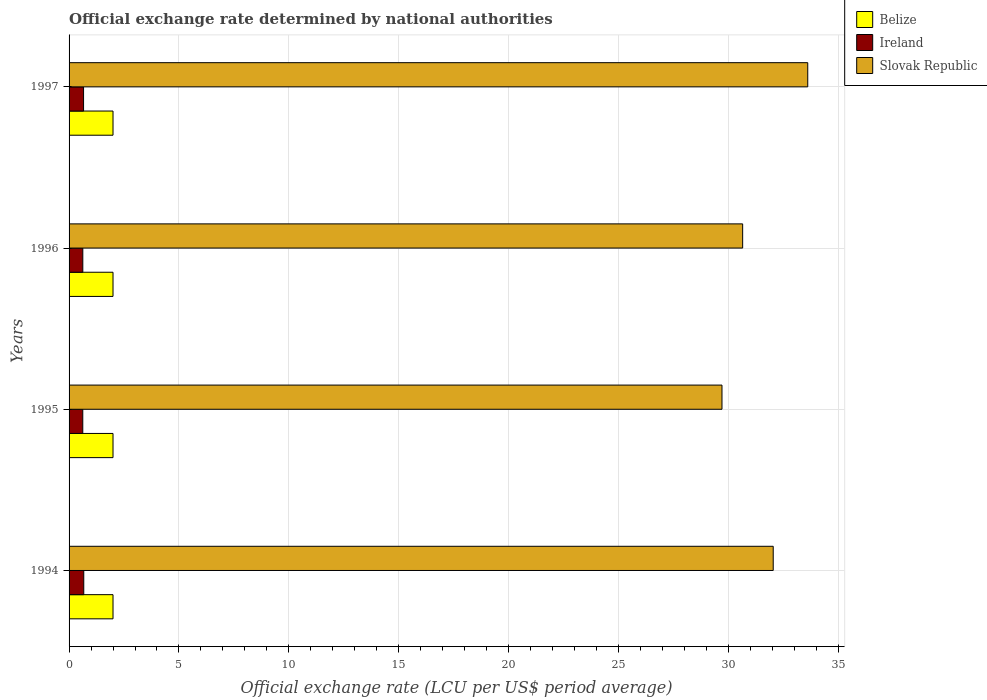How many different coloured bars are there?
Your response must be concise. 3. How many groups of bars are there?
Keep it short and to the point. 4. How many bars are there on the 3rd tick from the bottom?
Offer a terse response. 3. In how many cases, is the number of bars for a given year not equal to the number of legend labels?
Your answer should be compact. 0. What is the official exchange rate in Belize in 1996?
Your answer should be compact. 2. Across all years, what is the maximum official exchange rate in Slovak Republic?
Offer a very short reply. 33.62. Across all years, what is the minimum official exchange rate in Slovak Republic?
Your answer should be compact. 29.71. In which year was the official exchange rate in Ireland minimum?
Your response must be concise. 1995. What is the difference between the official exchange rate in Ireland in 1994 and that in 1997?
Provide a short and direct response. 0.01. What is the difference between the official exchange rate in Belize in 1994 and the official exchange rate in Ireland in 1995?
Ensure brevity in your answer.  1.38. In the year 1994, what is the difference between the official exchange rate in Ireland and official exchange rate in Belize?
Your answer should be very brief. -1.33. In how many years, is the official exchange rate in Slovak Republic greater than 16 LCU?
Make the answer very short. 4. What is the ratio of the official exchange rate in Ireland in 1994 to that in 1997?
Offer a terse response. 1.01. Is the official exchange rate in Slovak Republic in 1994 less than that in 1995?
Your response must be concise. No. What is the difference between the highest and the second highest official exchange rate in Slovak Republic?
Your answer should be compact. 1.57. What is the difference between the highest and the lowest official exchange rate in Ireland?
Offer a terse response. 0.04. In how many years, is the official exchange rate in Ireland greater than the average official exchange rate in Ireland taken over all years?
Provide a succinct answer. 2. What does the 3rd bar from the top in 1995 represents?
Provide a short and direct response. Belize. What does the 1st bar from the bottom in 1994 represents?
Offer a very short reply. Belize. Is it the case that in every year, the sum of the official exchange rate in Belize and official exchange rate in Ireland is greater than the official exchange rate in Slovak Republic?
Keep it short and to the point. No. How many bars are there?
Your response must be concise. 12. Does the graph contain grids?
Keep it short and to the point. Yes. Where does the legend appear in the graph?
Keep it short and to the point. Top right. How are the legend labels stacked?
Offer a terse response. Vertical. What is the title of the graph?
Give a very brief answer. Official exchange rate determined by national authorities. What is the label or title of the X-axis?
Your answer should be very brief. Official exchange rate (LCU per US$ period average). What is the label or title of the Y-axis?
Your answer should be very brief. Years. What is the Official exchange rate (LCU per US$ period average) of Belize in 1994?
Your response must be concise. 2. What is the Official exchange rate (LCU per US$ period average) in Ireland in 1994?
Keep it short and to the point. 0.67. What is the Official exchange rate (LCU per US$ period average) of Slovak Republic in 1994?
Keep it short and to the point. 32.04. What is the Official exchange rate (LCU per US$ period average) of Ireland in 1995?
Offer a very short reply. 0.62. What is the Official exchange rate (LCU per US$ period average) in Slovak Republic in 1995?
Your response must be concise. 29.71. What is the Official exchange rate (LCU per US$ period average) in Ireland in 1996?
Make the answer very short. 0.63. What is the Official exchange rate (LCU per US$ period average) of Slovak Republic in 1996?
Give a very brief answer. 30.65. What is the Official exchange rate (LCU per US$ period average) of Ireland in 1997?
Give a very brief answer. 0.66. What is the Official exchange rate (LCU per US$ period average) of Slovak Republic in 1997?
Keep it short and to the point. 33.62. Across all years, what is the maximum Official exchange rate (LCU per US$ period average) of Ireland?
Provide a succinct answer. 0.67. Across all years, what is the maximum Official exchange rate (LCU per US$ period average) of Slovak Republic?
Keep it short and to the point. 33.62. Across all years, what is the minimum Official exchange rate (LCU per US$ period average) of Ireland?
Your response must be concise. 0.62. Across all years, what is the minimum Official exchange rate (LCU per US$ period average) of Slovak Republic?
Offer a very short reply. 29.71. What is the total Official exchange rate (LCU per US$ period average) in Belize in the graph?
Your answer should be very brief. 8. What is the total Official exchange rate (LCU per US$ period average) of Ireland in the graph?
Your response must be concise. 2.58. What is the total Official exchange rate (LCU per US$ period average) of Slovak Republic in the graph?
Give a very brief answer. 126.03. What is the difference between the Official exchange rate (LCU per US$ period average) in Belize in 1994 and that in 1995?
Provide a short and direct response. 0. What is the difference between the Official exchange rate (LCU per US$ period average) of Ireland in 1994 and that in 1995?
Offer a very short reply. 0.04. What is the difference between the Official exchange rate (LCU per US$ period average) in Slovak Republic in 1994 and that in 1995?
Your answer should be compact. 2.33. What is the difference between the Official exchange rate (LCU per US$ period average) of Belize in 1994 and that in 1996?
Provide a short and direct response. 0. What is the difference between the Official exchange rate (LCU per US$ period average) in Ireland in 1994 and that in 1996?
Give a very brief answer. 0.04. What is the difference between the Official exchange rate (LCU per US$ period average) of Slovak Republic in 1994 and that in 1996?
Keep it short and to the point. 1.39. What is the difference between the Official exchange rate (LCU per US$ period average) of Belize in 1994 and that in 1997?
Give a very brief answer. 0. What is the difference between the Official exchange rate (LCU per US$ period average) of Ireland in 1994 and that in 1997?
Make the answer very short. 0.01. What is the difference between the Official exchange rate (LCU per US$ period average) in Slovak Republic in 1994 and that in 1997?
Keep it short and to the point. -1.57. What is the difference between the Official exchange rate (LCU per US$ period average) of Ireland in 1995 and that in 1996?
Your answer should be very brief. -0. What is the difference between the Official exchange rate (LCU per US$ period average) in Slovak Republic in 1995 and that in 1996?
Ensure brevity in your answer.  -0.94. What is the difference between the Official exchange rate (LCU per US$ period average) of Ireland in 1995 and that in 1997?
Your answer should be very brief. -0.04. What is the difference between the Official exchange rate (LCU per US$ period average) of Slovak Republic in 1995 and that in 1997?
Your response must be concise. -3.9. What is the difference between the Official exchange rate (LCU per US$ period average) in Ireland in 1996 and that in 1997?
Your response must be concise. -0.03. What is the difference between the Official exchange rate (LCU per US$ period average) of Slovak Republic in 1996 and that in 1997?
Ensure brevity in your answer.  -2.96. What is the difference between the Official exchange rate (LCU per US$ period average) of Belize in 1994 and the Official exchange rate (LCU per US$ period average) of Ireland in 1995?
Provide a succinct answer. 1.38. What is the difference between the Official exchange rate (LCU per US$ period average) in Belize in 1994 and the Official exchange rate (LCU per US$ period average) in Slovak Republic in 1995?
Your response must be concise. -27.71. What is the difference between the Official exchange rate (LCU per US$ period average) of Ireland in 1994 and the Official exchange rate (LCU per US$ period average) of Slovak Republic in 1995?
Provide a succinct answer. -29.04. What is the difference between the Official exchange rate (LCU per US$ period average) of Belize in 1994 and the Official exchange rate (LCU per US$ period average) of Ireland in 1996?
Offer a very short reply. 1.38. What is the difference between the Official exchange rate (LCU per US$ period average) in Belize in 1994 and the Official exchange rate (LCU per US$ period average) in Slovak Republic in 1996?
Offer a very short reply. -28.65. What is the difference between the Official exchange rate (LCU per US$ period average) of Ireland in 1994 and the Official exchange rate (LCU per US$ period average) of Slovak Republic in 1996?
Your answer should be very brief. -29.99. What is the difference between the Official exchange rate (LCU per US$ period average) in Belize in 1994 and the Official exchange rate (LCU per US$ period average) in Ireland in 1997?
Ensure brevity in your answer.  1.34. What is the difference between the Official exchange rate (LCU per US$ period average) of Belize in 1994 and the Official exchange rate (LCU per US$ period average) of Slovak Republic in 1997?
Ensure brevity in your answer.  -31.62. What is the difference between the Official exchange rate (LCU per US$ period average) in Ireland in 1994 and the Official exchange rate (LCU per US$ period average) in Slovak Republic in 1997?
Provide a short and direct response. -32.95. What is the difference between the Official exchange rate (LCU per US$ period average) in Belize in 1995 and the Official exchange rate (LCU per US$ period average) in Ireland in 1996?
Give a very brief answer. 1.38. What is the difference between the Official exchange rate (LCU per US$ period average) in Belize in 1995 and the Official exchange rate (LCU per US$ period average) in Slovak Republic in 1996?
Ensure brevity in your answer.  -28.65. What is the difference between the Official exchange rate (LCU per US$ period average) of Ireland in 1995 and the Official exchange rate (LCU per US$ period average) of Slovak Republic in 1996?
Provide a succinct answer. -30.03. What is the difference between the Official exchange rate (LCU per US$ period average) in Belize in 1995 and the Official exchange rate (LCU per US$ period average) in Ireland in 1997?
Offer a very short reply. 1.34. What is the difference between the Official exchange rate (LCU per US$ period average) of Belize in 1995 and the Official exchange rate (LCU per US$ period average) of Slovak Republic in 1997?
Your response must be concise. -31.62. What is the difference between the Official exchange rate (LCU per US$ period average) of Ireland in 1995 and the Official exchange rate (LCU per US$ period average) of Slovak Republic in 1997?
Give a very brief answer. -32.99. What is the difference between the Official exchange rate (LCU per US$ period average) of Belize in 1996 and the Official exchange rate (LCU per US$ period average) of Ireland in 1997?
Give a very brief answer. 1.34. What is the difference between the Official exchange rate (LCU per US$ period average) in Belize in 1996 and the Official exchange rate (LCU per US$ period average) in Slovak Republic in 1997?
Offer a terse response. -31.62. What is the difference between the Official exchange rate (LCU per US$ period average) in Ireland in 1996 and the Official exchange rate (LCU per US$ period average) in Slovak Republic in 1997?
Make the answer very short. -32.99. What is the average Official exchange rate (LCU per US$ period average) in Ireland per year?
Your response must be concise. 0.64. What is the average Official exchange rate (LCU per US$ period average) of Slovak Republic per year?
Your answer should be compact. 31.51. In the year 1994, what is the difference between the Official exchange rate (LCU per US$ period average) in Belize and Official exchange rate (LCU per US$ period average) in Ireland?
Your answer should be compact. 1.33. In the year 1994, what is the difference between the Official exchange rate (LCU per US$ period average) of Belize and Official exchange rate (LCU per US$ period average) of Slovak Republic?
Give a very brief answer. -30.04. In the year 1994, what is the difference between the Official exchange rate (LCU per US$ period average) of Ireland and Official exchange rate (LCU per US$ period average) of Slovak Republic?
Offer a terse response. -31.38. In the year 1995, what is the difference between the Official exchange rate (LCU per US$ period average) of Belize and Official exchange rate (LCU per US$ period average) of Ireland?
Give a very brief answer. 1.38. In the year 1995, what is the difference between the Official exchange rate (LCU per US$ period average) of Belize and Official exchange rate (LCU per US$ period average) of Slovak Republic?
Offer a terse response. -27.71. In the year 1995, what is the difference between the Official exchange rate (LCU per US$ period average) in Ireland and Official exchange rate (LCU per US$ period average) in Slovak Republic?
Ensure brevity in your answer.  -29.09. In the year 1996, what is the difference between the Official exchange rate (LCU per US$ period average) in Belize and Official exchange rate (LCU per US$ period average) in Ireland?
Give a very brief answer. 1.38. In the year 1996, what is the difference between the Official exchange rate (LCU per US$ period average) of Belize and Official exchange rate (LCU per US$ period average) of Slovak Republic?
Offer a very short reply. -28.65. In the year 1996, what is the difference between the Official exchange rate (LCU per US$ period average) of Ireland and Official exchange rate (LCU per US$ period average) of Slovak Republic?
Your response must be concise. -30.03. In the year 1997, what is the difference between the Official exchange rate (LCU per US$ period average) of Belize and Official exchange rate (LCU per US$ period average) of Ireland?
Provide a short and direct response. 1.34. In the year 1997, what is the difference between the Official exchange rate (LCU per US$ period average) of Belize and Official exchange rate (LCU per US$ period average) of Slovak Republic?
Provide a succinct answer. -31.62. In the year 1997, what is the difference between the Official exchange rate (LCU per US$ period average) of Ireland and Official exchange rate (LCU per US$ period average) of Slovak Republic?
Your answer should be very brief. -32.96. What is the ratio of the Official exchange rate (LCU per US$ period average) of Belize in 1994 to that in 1995?
Offer a terse response. 1. What is the ratio of the Official exchange rate (LCU per US$ period average) in Ireland in 1994 to that in 1995?
Your answer should be compact. 1.07. What is the ratio of the Official exchange rate (LCU per US$ period average) of Slovak Republic in 1994 to that in 1995?
Give a very brief answer. 1.08. What is the ratio of the Official exchange rate (LCU per US$ period average) in Ireland in 1994 to that in 1996?
Provide a succinct answer. 1.07. What is the ratio of the Official exchange rate (LCU per US$ period average) of Slovak Republic in 1994 to that in 1996?
Offer a terse response. 1.05. What is the ratio of the Official exchange rate (LCU per US$ period average) in Belize in 1994 to that in 1997?
Ensure brevity in your answer.  1. What is the ratio of the Official exchange rate (LCU per US$ period average) of Ireland in 1994 to that in 1997?
Keep it short and to the point. 1.01. What is the ratio of the Official exchange rate (LCU per US$ period average) of Slovak Republic in 1994 to that in 1997?
Give a very brief answer. 0.95. What is the ratio of the Official exchange rate (LCU per US$ period average) of Ireland in 1995 to that in 1996?
Give a very brief answer. 1. What is the ratio of the Official exchange rate (LCU per US$ period average) of Slovak Republic in 1995 to that in 1996?
Offer a terse response. 0.97. What is the ratio of the Official exchange rate (LCU per US$ period average) in Belize in 1995 to that in 1997?
Give a very brief answer. 1. What is the ratio of the Official exchange rate (LCU per US$ period average) in Ireland in 1995 to that in 1997?
Give a very brief answer. 0.95. What is the ratio of the Official exchange rate (LCU per US$ period average) of Slovak Republic in 1995 to that in 1997?
Give a very brief answer. 0.88. What is the ratio of the Official exchange rate (LCU per US$ period average) of Belize in 1996 to that in 1997?
Ensure brevity in your answer.  1. What is the ratio of the Official exchange rate (LCU per US$ period average) in Ireland in 1996 to that in 1997?
Keep it short and to the point. 0.95. What is the ratio of the Official exchange rate (LCU per US$ period average) in Slovak Republic in 1996 to that in 1997?
Offer a terse response. 0.91. What is the difference between the highest and the second highest Official exchange rate (LCU per US$ period average) of Belize?
Provide a short and direct response. 0. What is the difference between the highest and the second highest Official exchange rate (LCU per US$ period average) in Ireland?
Provide a short and direct response. 0.01. What is the difference between the highest and the second highest Official exchange rate (LCU per US$ period average) in Slovak Republic?
Your answer should be compact. 1.57. What is the difference between the highest and the lowest Official exchange rate (LCU per US$ period average) of Belize?
Your answer should be compact. 0. What is the difference between the highest and the lowest Official exchange rate (LCU per US$ period average) of Ireland?
Give a very brief answer. 0.04. What is the difference between the highest and the lowest Official exchange rate (LCU per US$ period average) in Slovak Republic?
Provide a succinct answer. 3.9. 